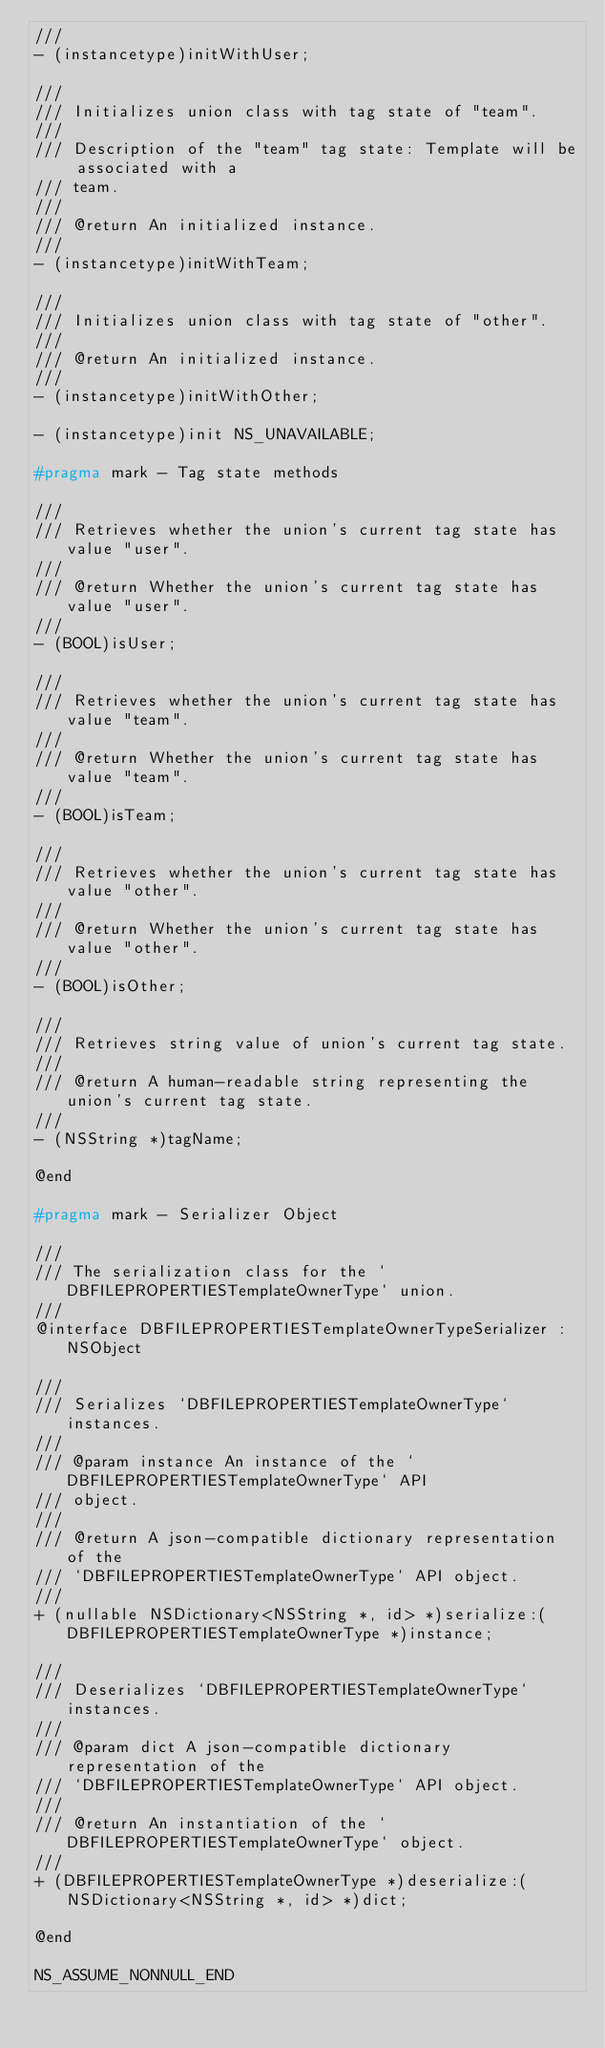Convert code to text. <code><loc_0><loc_0><loc_500><loc_500><_C_>///
- (instancetype)initWithUser;

///
/// Initializes union class with tag state of "team".
///
/// Description of the "team" tag state: Template will be associated with a
/// team.
///
/// @return An initialized instance.
///
- (instancetype)initWithTeam;

///
/// Initializes union class with tag state of "other".
///
/// @return An initialized instance.
///
- (instancetype)initWithOther;

- (instancetype)init NS_UNAVAILABLE;

#pragma mark - Tag state methods

///
/// Retrieves whether the union's current tag state has value "user".
///
/// @return Whether the union's current tag state has value "user".
///
- (BOOL)isUser;

///
/// Retrieves whether the union's current tag state has value "team".
///
/// @return Whether the union's current tag state has value "team".
///
- (BOOL)isTeam;

///
/// Retrieves whether the union's current tag state has value "other".
///
/// @return Whether the union's current tag state has value "other".
///
- (BOOL)isOther;

///
/// Retrieves string value of union's current tag state.
///
/// @return A human-readable string representing the union's current tag state.
///
- (NSString *)tagName;

@end

#pragma mark - Serializer Object

///
/// The serialization class for the `DBFILEPROPERTIESTemplateOwnerType` union.
///
@interface DBFILEPROPERTIESTemplateOwnerTypeSerializer : NSObject

///
/// Serializes `DBFILEPROPERTIESTemplateOwnerType` instances.
///
/// @param instance An instance of the `DBFILEPROPERTIESTemplateOwnerType` API
/// object.
///
/// @return A json-compatible dictionary representation of the
/// `DBFILEPROPERTIESTemplateOwnerType` API object.
///
+ (nullable NSDictionary<NSString *, id> *)serialize:(DBFILEPROPERTIESTemplateOwnerType *)instance;

///
/// Deserializes `DBFILEPROPERTIESTemplateOwnerType` instances.
///
/// @param dict A json-compatible dictionary representation of the
/// `DBFILEPROPERTIESTemplateOwnerType` API object.
///
/// @return An instantiation of the `DBFILEPROPERTIESTemplateOwnerType` object.
///
+ (DBFILEPROPERTIESTemplateOwnerType *)deserialize:(NSDictionary<NSString *, id> *)dict;

@end

NS_ASSUME_NONNULL_END
</code> 